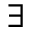Convert formula to latex. <formula><loc_0><loc_0><loc_500><loc_500>\exists</formula> 